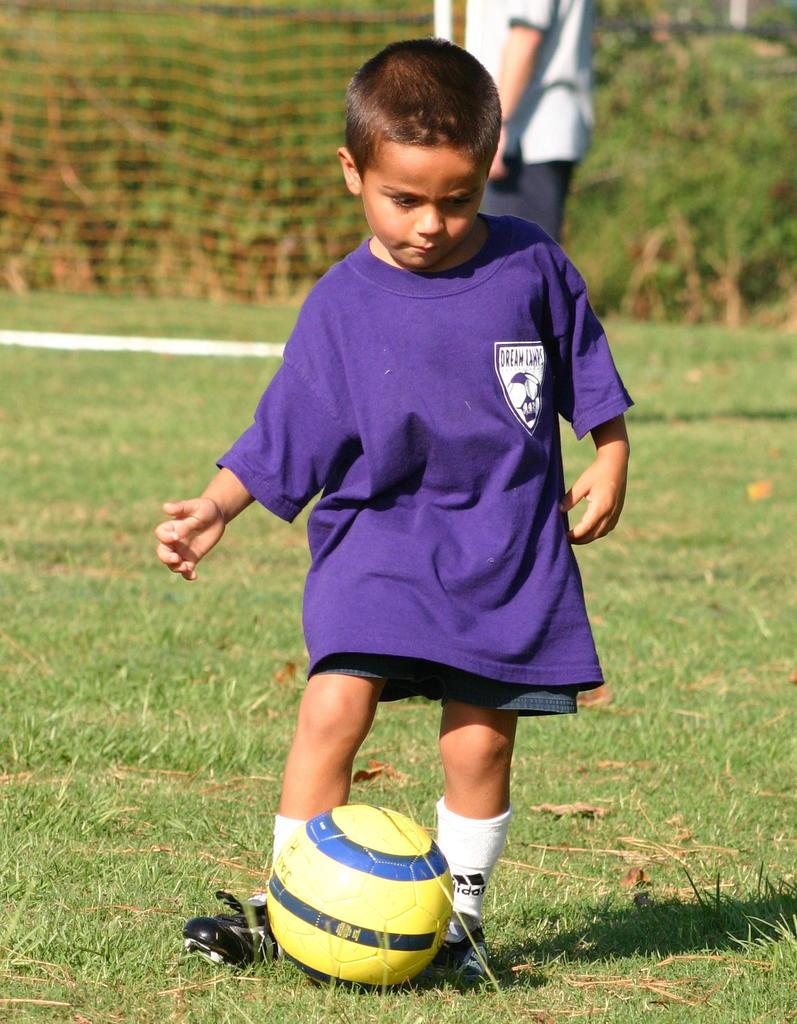Who is the main subject in the picture? There is a boy in the picture. What is the boy doing in the image? The boy is playing with a ball. Where is the ball located in the image? The ball is on the ground. What can be seen in the background of the image? There is a goal post and a person standing in the background of the image. What type of letters can be seen hanging from the goal post in the image? There are no letters hanging from the goal post in the image; only the boy, the ball, and the person standing can be seen. 